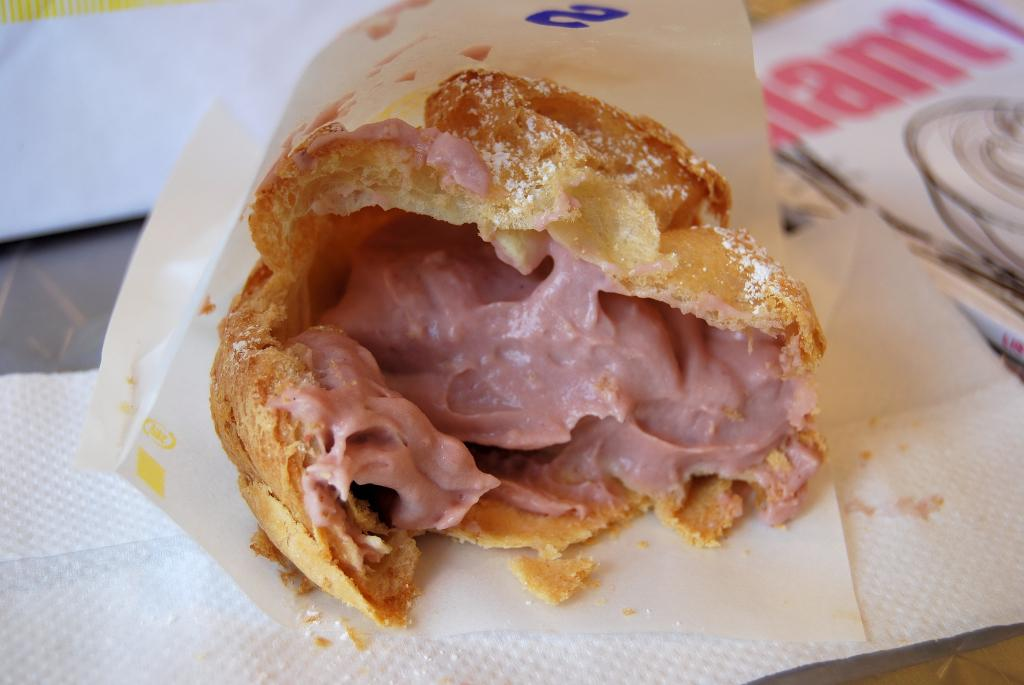What type of items can be seen in the image? There is food, tissue papers, and a book in the image. What might be used for cleaning or wiping in the image? Tissue papers are present in the image for cleaning or wiping. What type of object is the book in the image? The book is a type of object in the image. Where is the scarecrow located in the image? There is no scarecrow present in the image. What type of minister is depicted in the image? There is no minister depicted in the image. 